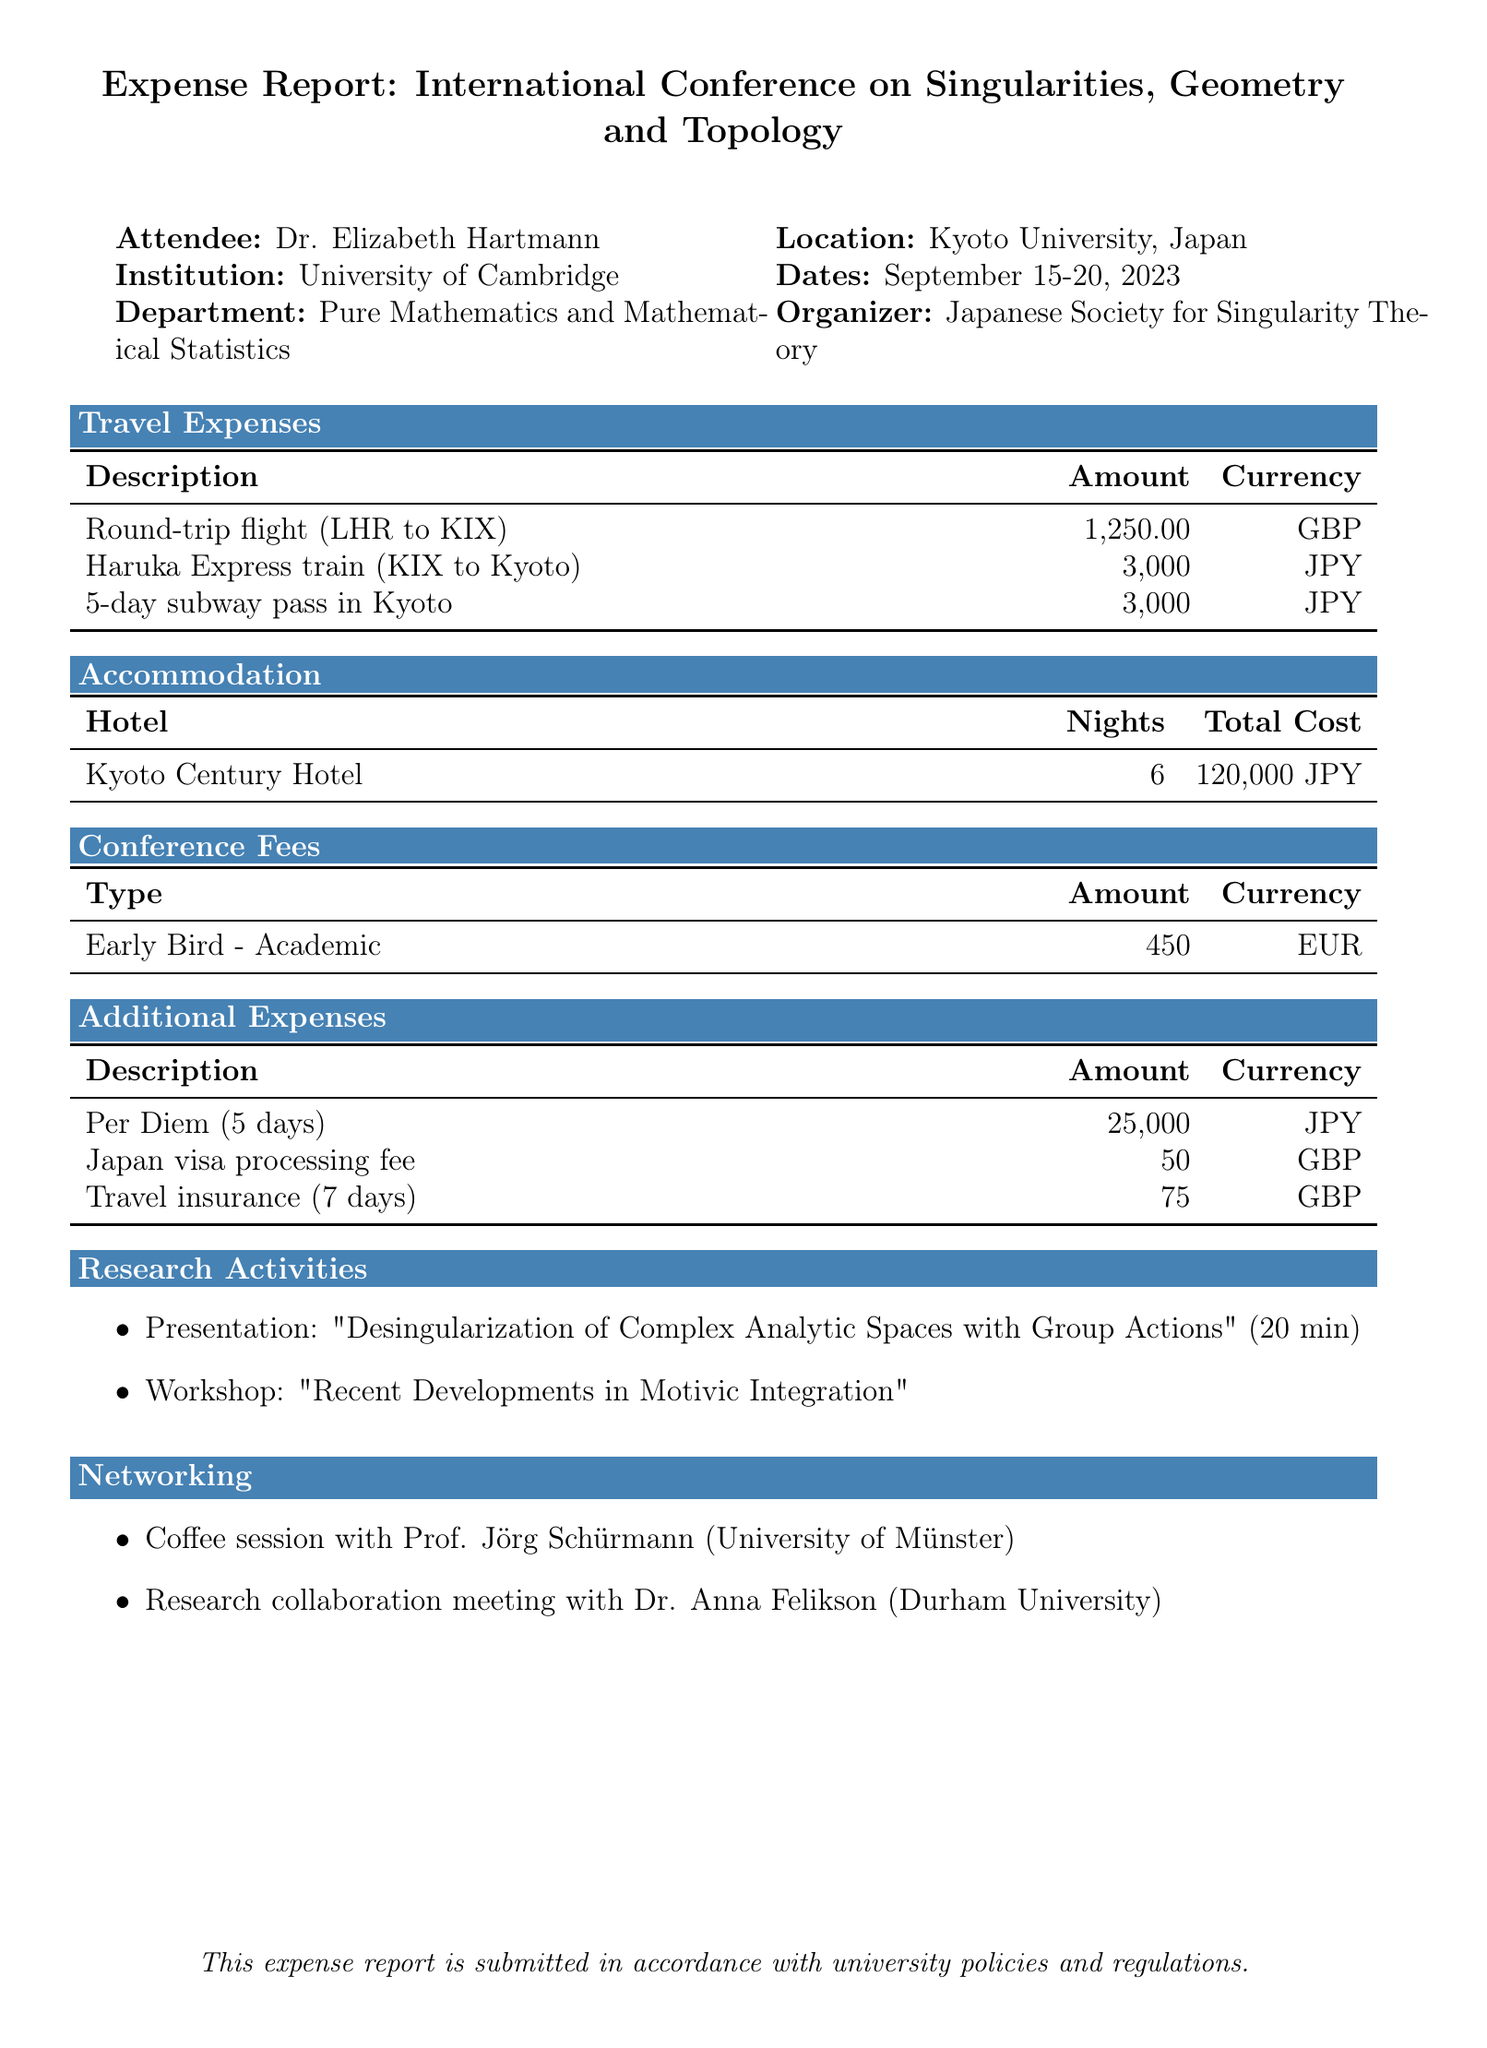What is the name of the conference? The conference is named "International Conference on Singularities, Geometry and Topology," as stated in the document.
Answer: International Conference on Singularities, Geometry and Topology What is the total accommodation cost? The total accommodation cost is provided under the accommodation section, which states it is 120,000 JPY.
Answer: 120,000 JPY Who is the attendee? The attendee is identified at the beginning of the document as Dr. Elizabeth Hartmann.
Answer: Dr. Elizabeth Hartmann What is the amount of the airfare? The airfare amount is found in the travel expenses section, which lists it as 1,250.00 GBP.
Answer: 1,250.00 GBP How many nights did the attendee stay at the hotel? The number of nights stayed is included in the accommodation section, stating it as 6 nights.
Answer: 6 What was the workshop title attended by the attendee? The title of the workshop is listed under research activities, which is "Recent Developments in Motivic Integration."
Answer: Recent Developments in Motivic Integration What is included in the conference registration fee? The document lists several inclusions under conference fees, specifically "Access to all sessions, Conference materials, Welcome reception, Coffee breaks, Conference dinner at Kiyomizu Temple."
Answer: Access to all sessions, Conference materials, Welcome reception, Coffee breaks, Conference dinner at Kiyomizu Temple What type of visa-related expense is documented? The documented visa-related expense is categorized under additional expenses, specifically the Japan visa processing fee.
Answer: Japan visa processing fee What is the total amount for meals not covered by the conference? The total amount is mentioned under meals, which states it as 25,000 JPY for meals not covered by the conference.
Answer: 25,000 JPY 